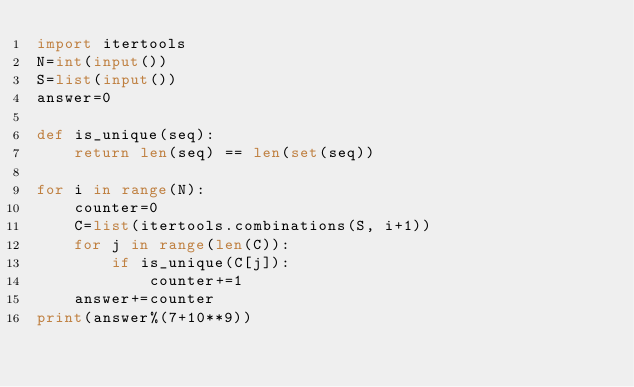<code> <loc_0><loc_0><loc_500><loc_500><_Python_>import itertools
N=int(input())
S=list(input())
answer=0

def is_unique(seq):
    return len(seq) == len(set(seq))

for i in range(N):
    counter=0
    C=list(itertools.combinations(S, i+1))
    for j in range(len(C)):
        if is_unique(C[j]):
            counter+=1
    answer+=counter
print(answer%(7+10**9))</code> 